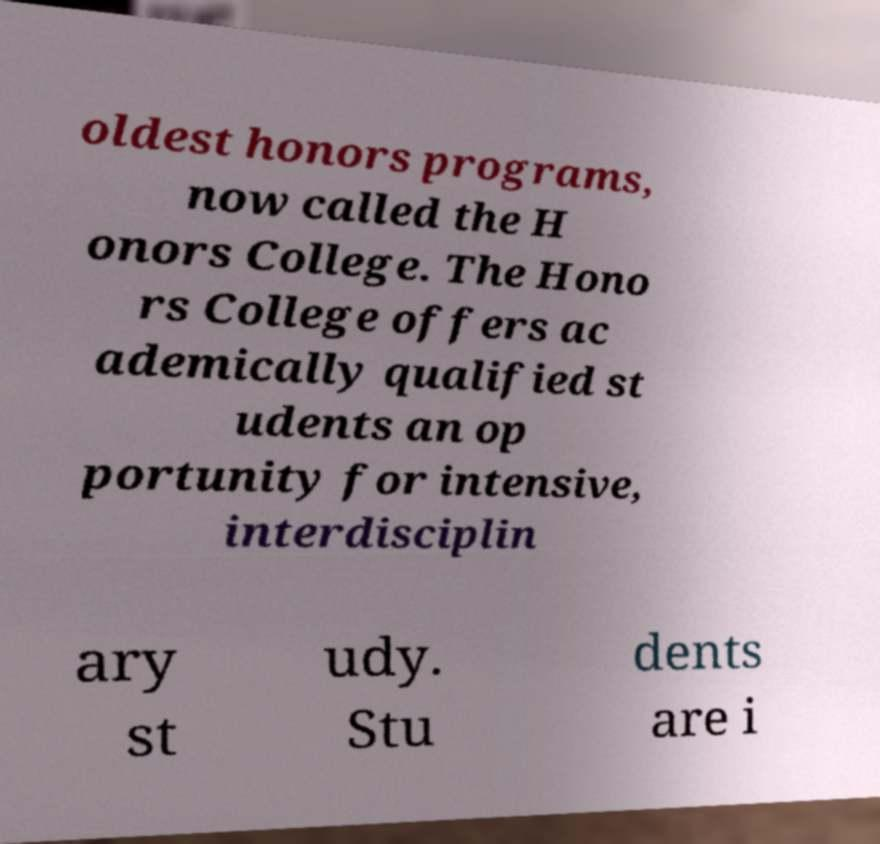Could you assist in decoding the text presented in this image and type it out clearly? oldest honors programs, now called the H onors College. The Hono rs College offers ac ademically qualified st udents an op portunity for intensive, interdisciplin ary st udy. Stu dents are i 